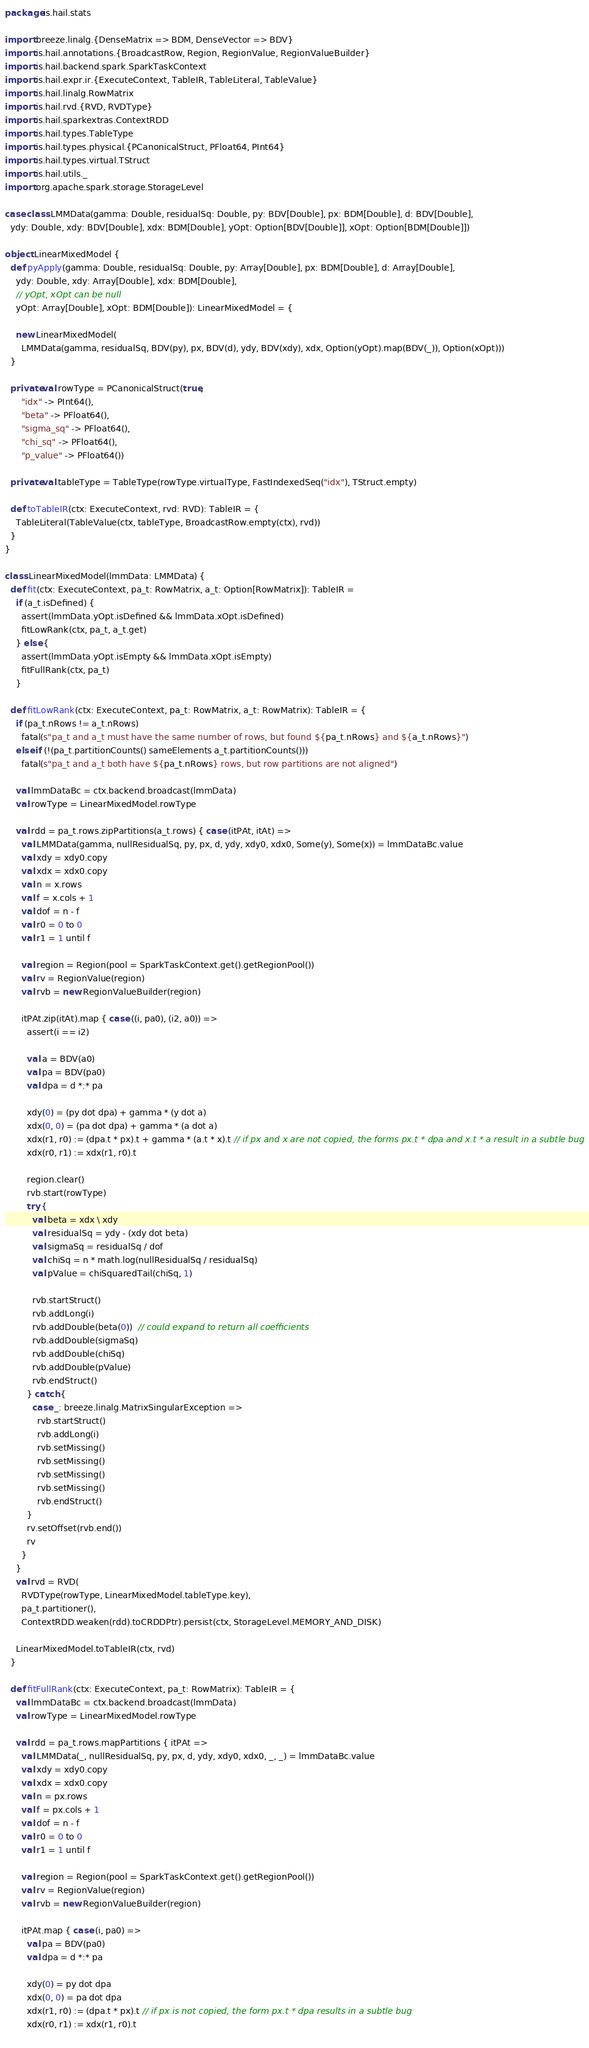Convert code to text. <code><loc_0><loc_0><loc_500><loc_500><_Scala_>package is.hail.stats

import breeze.linalg.{DenseMatrix => BDM, DenseVector => BDV}
import is.hail.annotations.{BroadcastRow, Region, RegionValue, RegionValueBuilder}
import is.hail.backend.spark.SparkTaskContext
import is.hail.expr.ir.{ExecuteContext, TableIR, TableLiteral, TableValue}
import is.hail.linalg.RowMatrix
import is.hail.rvd.{RVD, RVDType}
import is.hail.sparkextras.ContextRDD
import is.hail.types.TableType
import is.hail.types.physical.{PCanonicalStruct, PFloat64, PInt64}
import is.hail.types.virtual.TStruct
import is.hail.utils._
import org.apache.spark.storage.StorageLevel

case class LMMData(gamma: Double, residualSq: Double, py: BDV[Double], px: BDM[Double], d: BDV[Double],
  ydy: Double, xdy: BDV[Double], xdx: BDM[Double], yOpt: Option[BDV[Double]], xOpt: Option[BDM[Double]])

object LinearMixedModel {
  def pyApply(gamma: Double, residualSq: Double, py: Array[Double], px: BDM[Double], d: Array[Double],
    ydy: Double, xdy: Array[Double], xdx: BDM[Double],
    // yOpt, xOpt can be null
    yOpt: Array[Double], xOpt: BDM[Double]): LinearMixedModel = {

    new LinearMixedModel(
      LMMData(gamma, residualSq, BDV(py), px, BDV(d), ydy, BDV(xdy), xdx, Option(yOpt).map(BDV(_)), Option(xOpt)))
  }
  
  private val rowType = PCanonicalStruct(true,
      "idx" -> PInt64(),
      "beta" -> PFloat64(),
      "sigma_sq" -> PFloat64(),
      "chi_sq" -> PFloat64(),
      "p_value" -> PFloat64())

  private val tableType = TableType(rowType.virtualType, FastIndexedSeq("idx"), TStruct.empty)

  def toTableIR(ctx: ExecuteContext, rvd: RVD): TableIR = {
    TableLiteral(TableValue(ctx, tableType, BroadcastRow.empty(ctx), rvd))
  }
}

class LinearMixedModel(lmmData: LMMData) {
  def fit(ctx: ExecuteContext, pa_t: RowMatrix, a_t: Option[RowMatrix]): TableIR =
    if (a_t.isDefined) {
      assert(lmmData.yOpt.isDefined && lmmData.xOpt.isDefined)
      fitLowRank(ctx, pa_t, a_t.get)
    } else {
      assert(lmmData.yOpt.isEmpty && lmmData.xOpt.isEmpty)
      fitFullRank(ctx, pa_t)
    }

  def fitLowRank(ctx: ExecuteContext, pa_t: RowMatrix, a_t: RowMatrix): TableIR = {
    if (pa_t.nRows != a_t.nRows)
      fatal(s"pa_t and a_t must have the same number of rows, but found ${pa_t.nRows} and ${a_t.nRows}")
    else if (!(pa_t.partitionCounts() sameElements a_t.partitionCounts()))
      fatal(s"pa_t and a_t both have ${pa_t.nRows} rows, but row partitions are not aligned")

    val lmmDataBc = ctx.backend.broadcast(lmmData)
    val rowType = LinearMixedModel.rowType

    val rdd = pa_t.rows.zipPartitions(a_t.rows) { case (itPAt, itAt) =>
      val LMMData(gamma, nullResidualSq, py, px, d, ydy, xdy0, xdx0, Some(y), Some(x)) = lmmDataBc.value
      val xdy = xdy0.copy
      val xdx = xdx0.copy
      val n = x.rows
      val f = x.cols + 1
      val dof = n - f
      val r0 = 0 to 0
      val r1 = 1 until f

      val region = Region(pool = SparkTaskContext.get().getRegionPool())
      val rv = RegionValue(region)
      val rvb = new RegionValueBuilder(region)

      itPAt.zip(itAt).map { case ((i, pa0), (i2, a0)) =>
        assert(i == i2)

        val a = BDV(a0)
        val pa = BDV(pa0)
        val dpa = d *:* pa

        xdy(0) = (py dot dpa) + gamma * (y dot a)
        xdx(0, 0) = (pa dot dpa) + gamma * (a dot a)
        xdx(r1, r0) := (dpa.t * px).t + gamma * (a.t * x).t // if px and x are not copied, the forms px.t * dpa and x.t * a result in a subtle bug
        xdx(r0, r1) := xdx(r1, r0).t
       
        region.clear()
        rvb.start(rowType)
        try {
          val beta = xdx \ xdy
          val residualSq = ydy - (xdy dot beta)
          val sigmaSq = residualSq / dof
          val chiSq = n * math.log(nullResidualSq / residualSq)
          val pValue = chiSquaredTail(chiSq, 1)

          rvb.startStruct()
          rvb.addLong(i)
          rvb.addDouble(beta(0))  // could expand to return all coefficients
          rvb.addDouble(sigmaSq)
          rvb.addDouble(chiSq)
          rvb.addDouble(pValue)
          rvb.endStruct()
        } catch {
          case _: breeze.linalg.MatrixSingularException =>
            rvb.startStruct()
            rvb.addLong(i)
            rvb.setMissing()
            rvb.setMissing()
            rvb.setMissing()
            rvb.setMissing()
            rvb.endStruct()
        }
        rv.setOffset(rvb.end())
        rv
      }
    }
    val rvd = RVD(
      RVDType(rowType, LinearMixedModel.tableType.key),
      pa_t.partitioner(),
      ContextRDD.weaken(rdd).toCRDDPtr).persist(ctx, StorageLevel.MEMORY_AND_DISK)

    LinearMixedModel.toTableIR(ctx, rvd)
  }
  
  def fitFullRank(ctx: ExecuteContext, pa_t: RowMatrix): TableIR = {
    val lmmDataBc = ctx.backend.broadcast(lmmData)
    val rowType = LinearMixedModel.rowType
    
    val rdd = pa_t.rows.mapPartitions { itPAt =>
      val LMMData(_, nullResidualSq, py, px, d, ydy, xdy0, xdx0, _, _) = lmmDataBc.value
      val xdy = xdy0.copy
      val xdx = xdx0.copy
      val n = px.rows
      val f = px.cols + 1
      val dof = n - f
      val r0 = 0 to 0
      val r1 = 1 until f

      val region = Region(pool = SparkTaskContext.get().getRegionPool())
      val rv = RegionValue(region)
      val rvb = new RegionValueBuilder(region)

      itPAt.map { case (i, pa0) =>
        val pa = BDV(pa0)
        val dpa = d *:* pa

        xdy(0) = py dot dpa
        xdx(0, 0) = pa dot dpa
        xdx(r1, r0) := (dpa.t * px).t // if px is not copied, the form px.t * dpa results in a subtle bug
        xdx(r0, r1) := xdx(r1, r0).t
        </code> 